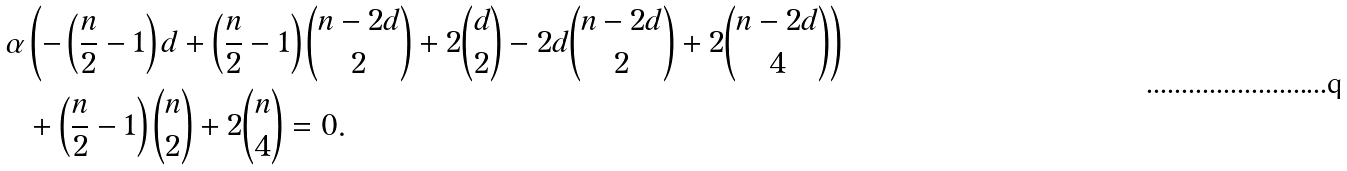<formula> <loc_0><loc_0><loc_500><loc_500>\alpha & \left ( - \left ( \frac { n } { 2 } - 1 \right ) d + \left ( \frac { n } { 2 } - 1 \right ) \binom { n - 2 d } { 2 } + 2 \binom { d } { 2 } - 2 d \binom { n - 2 d } { 2 } + 2 \binom { n - 2 d } { 4 } \right ) \\ & + \left ( \frac { n } { 2 } - 1 \right ) \binom { n } { 2 } + 2 \binom { n } { 4 } = 0 .</formula> 